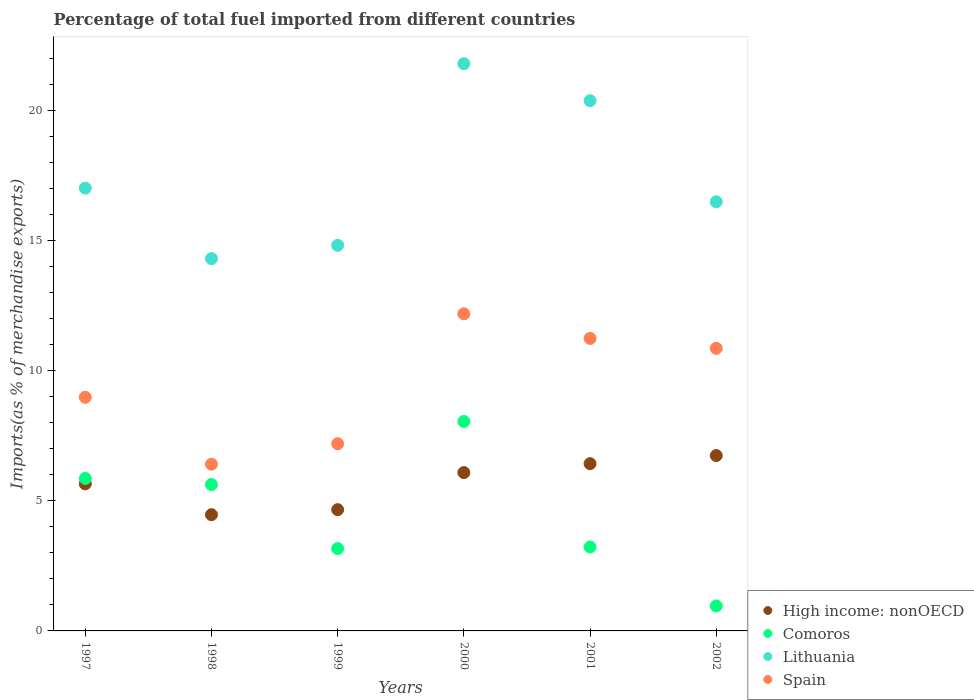How many different coloured dotlines are there?
Your response must be concise. 4. What is the percentage of imports to different countries in Comoros in 2000?
Make the answer very short. 8.04. Across all years, what is the maximum percentage of imports to different countries in Lithuania?
Offer a terse response. 21.78. Across all years, what is the minimum percentage of imports to different countries in Comoros?
Ensure brevity in your answer.  0.96. What is the total percentage of imports to different countries in High income: nonOECD in the graph?
Your answer should be compact. 34.01. What is the difference between the percentage of imports to different countries in Lithuania in 1998 and that in 2000?
Keep it short and to the point. -7.49. What is the difference between the percentage of imports to different countries in Comoros in 2002 and the percentage of imports to different countries in Spain in 1997?
Provide a short and direct response. -8.01. What is the average percentage of imports to different countries in High income: nonOECD per year?
Your answer should be compact. 5.67. In the year 1999, what is the difference between the percentage of imports to different countries in Lithuania and percentage of imports to different countries in Spain?
Offer a terse response. 7.62. What is the ratio of the percentage of imports to different countries in Lithuania in 2000 to that in 2001?
Your response must be concise. 1.07. What is the difference between the highest and the second highest percentage of imports to different countries in Comoros?
Give a very brief answer. 2.19. What is the difference between the highest and the lowest percentage of imports to different countries in High income: nonOECD?
Make the answer very short. 2.27. In how many years, is the percentage of imports to different countries in Comoros greater than the average percentage of imports to different countries in Comoros taken over all years?
Provide a short and direct response. 3. Is the sum of the percentage of imports to different countries in Comoros in 1997 and 1999 greater than the maximum percentage of imports to different countries in Spain across all years?
Keep it short and to the point. No. What is the difference between two consecutive major ticks on the Y-axis?
Ensure brevity in your answer.  5. Are the values on the major ticks of Y-axis written in scientific E-notation?
Your response must be concise. No. Does the graph contain any zero values?
Your answer should be very brief. No. How many legend labels are there?
Offer a terse response. 4. How are the legend labels stacked?
Offer a very short reply. Vertical. What is the title of the graph?
Your response must be concise. Percentage of total fuel imported from different countries. Does "Chad" appear as one of the legend labels in the graph?
Your answer should be compact. No. What is the label or title of the X-axis?
Keep it short and to the point. Years. What is the label or title of the Y-axis?
Offer a very short reply. Imports(as % of merchandise exports). What is the Imports(as % of merchandise exports) in High income: nonOECD in 1997?
Make the answer very short. 5.65. What is the Imports(as % of merchandise exports) of Comoros in 1997?
Offer a very short reply. 5.86. What is the Imports(as % of merchandise exports) of Lithuania in 1997?
Your response must be concise. 17. What is the Imports(as % of merchandise exports) in Spain in 1997?
Your answer should be compact. 8.97. What is the Imports(as % of merchandise exports) in High income: nonOECD in 1998?
Make the answer very short. 4.46. What is the Imports(as % of merchandise exports) of Comoros in 1998?
Your answer should be very brief. 5.62. What is the Imports(as % of merchandise exports) of Lithuania in 1998?
Your response must be concise. 14.3. What is the Imports(as % of merchandise exports) in Spain in 1998?
Your response must be concise. 6.4. What is the Imports(as % of merchandise exports) in High income: nonOECD in 1999?
Ensure brevity in your answer.  4.66. What is the Imports(as % of merchandise exports) in Comoros in 1999?
Offer a terse response. 3.16. What is the Imports(as % of merchandise exports) in Lithuania in 1999?
Ensure brevity in your answer.  14.81. What is the Imports(as % of merchandise exports) of Spain in 1999?
Ensure brevity in your answer.  7.19. What is the Imports(as % of merchandise exports) in High income: nonOECD in 2000?
Ensure brevity in your answer.  6.08. What is the Imports(as % of merchandise exports) in Comoros in 2000?
Offer a terse response. 8.04. What is the Imports(as % of merchandise exports) in Lithuania in 2000?
Your response must be concise. 21.78. What is the Imports(as % of merchandise exports) of Spain in 2000?
Your answer should be compact. 12.18. What is the Imports(as % of merchandise exports) in High income: nonOECD in 2001?
Provide a succinct answer. 6.42. What is the Imports(as % of merchandise exports) in Comoros in 2001?
Offer a very short reply. 3.22. What is the Imports(as % of merchandise exports) in Lithuania in 2001?
Ensure brevity in your answer.  20.36. What is the Imports(as % of merchandise exports) in Spain in 2001?
Provide a short and direct response. 11.23. What is the Imports(as % of merchandise exports) of High income: nonOECD in 2002?
Make the answer very short. 6.73. What is the Imports(as % of merchandise exports) in Comoros in 2002?
Your response must be concise. 0.96. What is the Imports(as % of merchandise exports) in Lithuania in 2002?
Offer a very short reply. 16.48. What is the Imports(as % of merchandise exports) of Spain in 2002?
Ensure brevity in your answer.  10.85. Across all years, what is the maximum Imports(as % of merchandise exports) in High income: nonOECD?
Keep it short and to the point. 6.73. Across all years, what is the maximum Imports(as % of merchandise exports) of Comoros?
Provide a short and direct response. 8.04. Across all years, what is the maximum Imports(as % of merchandise exports) in Lithuania?
Offer a terse response. 21.78. Across all years, what is the maximum Imports(as % of merchandise exports) in Spain?
Keep it short and to the point. 12.18. Across all years, what is the minimum Imports(as % of merchandise exports) in High income: nonOECD?
Keep it short and to the point. 4.46. Across all years, what is the minimum Imports(as % of merchandise exports) in Comoros?
Provide a succinct answer. 0.96. Across all years, what is the minimum Imports(as % of merchandise exports) of Lithuania?
Your response must be concise. 14.3. Across all years, what is the minimum Imports(as % of merchandise exports) of Spain?
Provide a succinct answer. 6.4. What is the total Imports(as % of merchandise exports) in High income: nonOECD in the graph?
Your answer should be very brief. 34.01. What is the total Imports(as % of merchandise exports) in Comoros in the graph?
Offer a terse response. 26.86. What is the total Imports(as % of merchandise exports) in Lithuania in the graph?
Ensure brevity in your answer.  104.73. What is the total Imports(as % of merchandise exports) of Spain in the graph?
Your answer should be compact. 56.82. What is the difference between the Imports(as % of merchandise exports) of High income: nonOECD in 1997 and that in 1998?
Offer a terse response. 1.18. What is the difference between the Imports(as % of merchandise exports) in Comoros in 1997 and that in 1998?
Give a very brief answer. 0.24. What is the difference between the Imports(as % of merchandise exports) in Lithuania in 1997 and that in 1998?
Ensure brevity in your answer.  2.71. What is the difference between the Imports(as % of merchandise exports) of Spain in 1997 and that in 1998?
Offer a terse response. 2.57. What is the difference between the Imports(as % of merchandise exports) of High income: nonOECD in 1997 and that in 1999?
Give a very brief answer. 0.99. What is the difference between the Imports(as % of merchandise exports) of Comoros in 1997 and that in 1999?
Your response must be concise. 2.7. What is the difference between the Imports(as % of merchandise exports) in Lithuania in 1997 and that in 1999?
Offer a very short reply. 2.2. What is the difference between the Imports(as % of merchandise exports) of Spain in 1997 and that in 1999?
Your response must be concise. 1.78. What is the difference between the Imports(as % of merchandise exports) of High income: nonOECD in 1997 and that in 2000?
Offer a terse response. -0.43. What is the difference between the Imports(as % of merchandise exports) in Comoros in 1997 and that in 2000?
Ensure brevity in your answer.  -2.19. What is the difference between the Imports(as % of merchandise exports) of Lithuania in 1997 and that in 2000?
Offer a terse response. -4.78. What is the difference between the Imports(as % of merchandise exports) in Spain in 1997 and that in 2000?
Keep it short and to the point. -3.21. What is the difference between the Imports(as % of merchandise exports) of High income: nonOECD in 1997 and that in 2001?
Your response must be concise. -0.78. What is the difference between the Imports(as % of merchandise exports) of Comoros in 1997 and that in 2001?
Offer a terse response. 2.63. What is the difference between the Imports(as % of merchandise exports) of Lithuania in 1997 and that in 2001?
Keep it short and to the point. -3.36. What is the difference between the Imports(as % of merchandise exports) in Spain in 1997 and that in 2001?
Ensure brevity in your answer.  -2.26. What is the difference between the Imports(as % of merchandise exports) of High income: nonOECD in 1997 and that in 2002?
Keep it short and to the point. -1.09. What is the difference between the Imports(as % of merchandise exports) in Comoros in 1997 and that in 2002?
Provide a succinct answer. 4.9. What is the difference between the Imports(as % of merchandise exports) of Lithuania in 1997 and that in 2002?
Offer a very short reply. 0.53. What is the difference between the Imports(as % of merchandise exports) of Spain in 1997 and that in 2002?
Your answer should be compact. -1.88. What is the difference between the Imports(as % of merchandise exports) of High income: nonOECD in 1998 and that in 1999?
Offer a very short reply. -0.19. What is the difference between the Imports(as % of merchandise exports) in Comoros in 1998 and that in 1999?
Provide a short and direct response. 2.46. What is the difference between the Imports(as % of merchandise exports) in Lithuania in 1998 and that in 1999?
Provide a succinct answer. -0.51. What is the difference between the Imports(as % of merchandise exports) in Spain in 1998 and that in 1999?
Make the answer very short. -0.79. What is the difference between the Imports(as % of merchandise exports) in High income: nonOECD in 1998 and that in 2000?
Provide a succinct answer. -1.62. What is the difference between the Imports(as % of merchandise exports) in Comoros in 1998 and that in 2000?
Provide a short and direct response. -2.42. What is the difference between the Imports(as % of merchandise exports) of Lithuania in 1998 and that in 2000?
Ensure brevity in your answer.  -7.49. What is the difference between the Imports(as % of merchandise exports) in Spain in 1998 and that in 2000?
Provide a succinct answer. -5.77. What is the difference between the Imports(as % of merchandise exports) of High income: nonOECD in 1998 and that in 2001?
Make the answer very short. -1.96. What is the difference between the Imports(as % of merchandise exports) of Comoros in 1998 and that in 2001?
Offer a terse response. 2.4. What is the difference between the Imports(as % of merchandise exports) in Lithuania in 1998 and that in 2001?
Your answer should be very brief. -6.06. What is the difference between the Imports(as % of merchandise exports) in Spain in 1998 and that in 2001?
Keep it short and to the point. -4.83. What is the difference between the Imports(as % of merchandise exports) of High income: nonOECD in 1998 and that in 2002?
Your response must be concise. -2.27. What is the difference between the Imports(as % of merchandise exports) in Comoros in 1998 and that in 2002?
Provide a succinct answer. 4.66. What is the difference between the Imports(as % of merchandise exports) in Lithuania in 1998 and that in 2002?
Make the answer very short. -2.18. What is the difference between the Imports(as % of merchandise exports) of Spain in 1998 and that in 2002?
Keep it short and to the point. -4.45. What is the difference between the Imports(as % of merchandise exports) of High income: nonOECD in 1999 and that in 2000?
Offer a very short reply. -1.42. What is the difference between the Imports(as % of merchandise exports) of Comoros in 1999 and that in 2000?
Make the answer very short. -4.88. What is the difference between the Imports(as % of merchandise exports) of Lithuania in 1999 and that in 2000?
Your answer should be compact. -6.97. What is the difference between the Imports(as % of merchandise exports) of Spain in 1999 and that in 2000?
Provide a succinct answer. -4.99. What is the difference between the Imports(as % of merchandise exports) in High income: nonOECD in 1999 and that in 2001?
Your response must be concise. -1.77. What is the difference between the Imports(as % of merchandise exports) of Comoros in 1999 and that in 2001?
Ensure brevity in your answer.  -0.06. What is the difference between the Imports(as % of merchandise exports) in Lithuania in 1999 and that in 2001?
Make the answer very short. -5.55. What is the difference between the Imports(as % of merchandise exports) in Spain in 1999 and that in 2001?
Keep it short and to the point. -4.04. What is the difference between the Imports(as % of merchandise exports) in High income: nonOECD in 1999 and that in 2002?
Your answer should be compact. -2.08. What is the difference between the Imports(as % of merchandise exports) of Comoros in 1999 and that in 2002?
Your response must be concise. 2.2. What is the difference between the Imports(as % of merchandise exports) in Lithuania in 1999 and that in 2002?
Your answer should be compact. -1.67. What is the difference between the Imports(as % of merchandise exports) in Spain in 1999 and that in 2002?
Provide a short and direct response. -3.66. What is the difference between the Imports(as % of merchandise exports) of High income: nonOECD in 2000 and that in 2001?
Make the answer very short. -0.34. What is the difference between the Imports(as % of merchandise exports) of Comoros in 2000 and that in 2001?
Provide a succinct answer. 4.82. What is the difference between the Imports(as % of merchandise exports) of Lithuania in 2000 and that in 2001?
Make the answer very short. 1.42. What is the difference between the Imports(as % of merchandise exports) of Spain in 2000 and that in 2001?
Provide a succinct answer. 0.94. What is the difference between the Imports(as % of merchandise exports) of High income: nonOECD in 2000 and that in 2002?
Offer a very short reply. -0.65. What is the difference between the Imports(as % of merchandise exports) in Comoros in 2000 and that in 2002?
Keep it short and to the point. 7.08. What is the difference between the Imports(as % of merchandise exports) of Lithuania in 2000 and that in 2002?
Your answer should be very brief. 5.3. What is the difference between the Imports(as % of merchandise exports) in Spain in 2000 and that in 2002?
Offer a terse response. 1.33. What is the difference between the Imports(as % of merchandise exports) in High income: nonOECD in 2001 and that in 2002?
Give a very brief answer. -0.31. What is the difference between the Imports(as % of merchandise exports) of Comoros in 2001 and that in 2002?
Your answer should be compact. 2.26. What is the difference between the Imports(as % of merchandise exports) in Lithuania in 2001 and that in 2002?
Offer a terse response. 3.88. What is the difference between the Imports(as % of merchandise exports) of Spain in 2001 and that in 2002?
Offer a very short reply. 0.38. What is the difference between the Imports(as % of merchandise exports) in High income: nonOECD in 1997 and the Imports(as % of merchandise exports) in Comoros in 1998?
Your response must be concise. 0.03. What is the difference between the Imports(as % of merchandise exports) of High income: nonOECD in 1997 and the Imports(as % of merchandise exports) of Lithuania in 1998?
Ensure brevity in your answer.  -8.65. What is the difference between the Imports(as % of merchandise exports) of High income: nonOECD in 1997 and the Imports(as % of merchandise exports) of Spain in 1998?
Provide a short and direct response. -0.76. What is the difference between the Imports(as % of merchandise exports) of Comoros in 1997 and the Imports(as % of merchandise exports) of Lithuania in 1998?
Your answer should be compact. -8.44. What is the difference between the Imports(as % of merchandise exports) of Comoros in 1997 and the Imports(as % of merchandise exports) of Spain in 1998?
Keep it short and to the point. -0.55. What is the difference between the Imports(as % of merchandise exports) in Lithuania in 1997 and the Imports(as % of merchandise exports) in Spain in 1998?
Provide a succinct answer. 10.6. What is the difference between the Imports(as % of merchandise exports) in High income: nonOECD in 1997 and the Imports(as % of merchandise exports) in Comoros in 1999?
Your answer should be very brief. 2.49. What is the difference between the Imports(as % of merchandise exports) of High income: nonOECD in 1997 and the Imports(as % of merchandise exports) of Lithuania in 1999?
Ensure brevity in your answer.  -9.16. What is the difference between the Imports(as % of merchandise exports) of High income: nonOECD in 1997 and the Imports(as % of merchandise exports) of Spain in 1999?
Keep it short and to the point. -1.54. What is the difference between the Imports(as % of merchandise exports) of Comoros in 1997 and the Imports(as % of merchandise exports) of Lithuania in 1999?
Your response must be concise. -8.95. What is the difference between the Imports(as % of merchandise exports) in Comoros in 1997 and the Imports(as % of merchandise exports) in Spain in 1999?
Your response must be concise. -1.33. What is the difference between the Imports(as % of merchandise exports) in Lithuania in 1997 and the Imports(as % of merchandise exports) in Spain in 1999?
Your response must be concise. 9.82. What is the difference between the Imports(as % of merchandise exports) of High income: nonOECD in 1997 and the Imports(as % of merchandise exports) of Comoros in 2000?
Your answer should be compact. -2.4. What is the difference between the Imports(as % of merchandise exports) in High income: nonOECD in 1997 and the Imports(as % of merchandise exports) in Lithuania in 2000?
Provide a succinct answer. -16.14. What is the difference between the Imports(as % of merchandise exports) of High income: nonOECD in 1997 and the Imports(as % of merchandise exports) of Spain in 2000?
Give a very brief answer. -6.53. What is the difference between the Imports(as % of merchandise exports) of Comoros in 1997 and the Imports(as % of merchandise exports) of Lithuania in 2000?
Your response must be concise. -15.93. What is the difference between the Imports(as % of merchandise exports) in Comoros in 1997 and the Imports(as % of merchandise exports) in Spain in 2000?
Offer a terse response. -6.32. What is the difference between the Imports(as % of merchandise exports) in Lithuania in 1997 and the Imports(as % of merchandise exports) in Spain in 2000?
Provide a succinct answer. 4.83. What is the difference between the Imports(as % of merchandise exports) in High income: nonOECD in 1997 and the Imports(as % of merchandise exports) in Comoros in 2001?
Give a very brief answer. 2.42. What is the difference between the Imports(as % of merchandise exports) of High income: nonOECD in 1997 and the Imports(as % of merchandise exports) of Lithuania in 2001?
Your answer should be very brief. -14.71. What is the difference between the Imports(as % of merchandise exports) in High income: nonOECD in 1997 and the Imports(as % of merchandise exports) in Spain in 2001?
Offer a terse response. -5.59. What is the difference between the Imports(as % of merchandise exports) of Comoros in 1997 and the Imports(as % of merchandise exports) of Lithuania in 2001?
Give a very brief answer. -14.51. What is the difference between the Imports(as % of merchandise exports) of Comoros in 1997 and the Imports(as % of merchandise exports) of Spain in 2001?
Make the answer very short. -5.38. What is the difference between the Imports(as % of merchandise exports) in Lithuania in 1997 and the Imports(as % of merchandise exports) in Spain in 2001?
Give a very brief answer. 5.77. What is the difference between the Imports(as % of merchandise exports) in High income: nonOECD in 1997 and the Imports(as % of merchandise exports) in Comoros in 2002?
Provide a succinct answer. 4.69. What is the difference between the Imports(as % of merchandise exports) of High income: nonOECD in 1997 and the Imports(as % of merchandise exports) of Lithuania in 2002?
Make the answer very short. -10.83. What is the difference between the Imports(as % of merchandise exports) in High income: nonOECD in 1997 and the Imports(as % of merchandise exports) in Spain in 2002?
Your answer should be very brief. -5.21. What is the difference between the Imports(as % of merchandise exports) in Comoros in 1997 and the Imports(as % of merchandise exports) in Lithuania in 2002?
Keep it short and to the point. -10.62. What is the difference between the Imports(as % of merchandise exports) of Comoros in 1997 and the Imports(as % of merchandise exports) of Spain in 2002?
Offer a very short reply. -5. What is the difference between the Imports(as % of merchandise exports) of Lithuania in 1997 and the Imports(as % of merchandise exports) of Spain in 2002?
Your answer should be compact. 6.15. What is the difference between the Imports(as % of merchandise exports) of High income: nonOECD in 1998 and the Imports(as % of merchandise exports) of Comoros in 1999?
Your response must be concise. 1.3. What is the difference between the Imports(as % of merchandise exports) in High income: nonOECD in 1998 and the Imports(as % of merchandise exports) in Lithuania in 1999?
Keep it short and to the point. -10.35. What is the difference between the Imports(as % of merchandise exports) of High income: nonOECD in 1998 and the Imports(as % of merchandise exports) of Spain in 1999?
Provide a short and direct response. -2.73. What is the difference between the Imports(as % of merchandise exports) of Comoros in 1998 and the Imports(as % of merchandise exports) of Lithuania in 1999?
Give a very brief answer. -9.19. What is the difference between the Imports(as % of merchandise exports) of Comoros in 1998 and the Imports(as % of merchandise exports) of Spain in 1999?
Provide a short and direct response. -1.57. What is the difference between the Imports(as % of merchandise exports) in Lithuania in 1998 and the Imports(as % of merchandise exports) in Spain in 1999?
Your response must be concise. 7.11. What is the difference between the Imports(as % of merchandise exports) of High income: nonOECD in 1998 and the Imports(as % of merchandise exports) of Comoros in 2000?
Your answer should be very brief. -3.58. What is the difference between the Imports(as % of merchandise exports) of High income: nonOECD in 1998 and the Imports(as % of merchandise exports) of Lithuania in 2000?
Provide a short and direct response. -17.32. What is the difference between the Imports(as % of merchandise exports) of High income: nonOECD in 1998 and the Imports(as % of merchandise exports) of Spain in 2000?
Offer a terse response. -7.71. What is the difference between the Imports(as % of merchandise exports) of Comoros in 1998 and the Imports(as % of merchandise exports) of Lithuania in 2000?
Provide a short and direct response. -16.16. What is the difference between the Imports(as % of merchandise exports) in Comoros in 1998 and the Imports(as % of merchandise exports) in Spain in 2000?
Provide a succinct answer. -6.56. What is the difference between the Imports(as % of merchandise exports) of Lithuania in 1998 and the Imports(as % of merchandise exports) of Spain in 2000?
Keep it short and to the point. 2.12. What is the difference between the Imports(as % of merchandise exports) of High income: nonOECD in 1998 and the Imports(as % of merchandise exports) of Comoros in 2001?
Ensure brevity in your answer.  1.24. What is the difference between the Imports(as % of merchandise exports) of High income: nonOECD in 1998 and the Imports(as % of merchandise exports) of Lithuania in 2001?
Provide a succinct answer. -15.9. What is the difference between the Imports(as % of merchandise exports) in High income: nonOECD in 1998 and the Imports(as % of merchandise exports) in Spain in 2001?
Make the answer very short. -6.77. What is the difference between the Imports(as % of merchandise exports) of Comoros in 1998 and the Imports(as % of merchandise exports) of Lithuania in 2001?
Offer a very short reply. -14.74. What is the difference between the Imports(as % of merchandise exports) of Comoros in 1998 and the Imports(as % of merchandise exports) of Spain in 2001?
Keep it short and to the point. -5.61. What is the difference between the Imports(as % of merchandise exports) in Lithuania in 1998 and the Imports(as % of merchandise exports) in Spain in 2001?
Offer a very short reply. 3.06. What is the difference between the Imports(as % of merchandise exports) of High income: nonOECD in 1998 and the Imports(as % of merchandise exports) of Comoros in 2002?
Your response must be concise. 3.5. What is the difference between the Imports(as % of merchandise exports) of High income: nonOECD in 1998 and the Imports(as % of merchandise exports) of Lithuania in 2002?
Offer a very short reply. -12.02. What is the difference between the Imports(as % of merchandise exports) of High income: nonOECD in 1998 and the Imports(as % of merchandise exports) of Spain in 2002?
Your response must be concise. -6.39. What is the difference between the Imports(as % of merchandise exports) in Comoros in 1998 and the Imports(as % of merchandise exports) in Lithuania in 2002?
Give a very brief answer. -10.86. What is the difference between the Imports(as % of merchandise exports) in Comoros in 1998 and the Imports(as % of merchandise exports) in Spain in 2002?
Give a very brief answer. -5.23. What is the difference between the Imports(as % of merchandise exports) in Lithuania in 1998 and the Imports(as % of merchandise exports) in Spain in 2002?
Make the answer very short. 3.44. What is the difference between the Imports(as % of merchandise exports) in High income: nonOECD in 1999 and the Imports(as % of merchandise exports) in Comoros in 2000?
Make the answer very short. -3.39. What is the difference between the Imports(as % of merchandise exports) in High income: nonOECD in 1999 and the Imports(as % of merchandise exports) in Lithuania in 2000?
Ensure brevity in your answer.  -17.13. What is the difference between the Imports(as % of merchandise exports) in High income: nonOECD in 1999 and the Imports(as % of merchandise exports) in Spain in 2000?
Your answer should be very brief. -7.52. What is the difference between the Imports(as % of merchandise exports) of Comoros in 1999 and the Imports(as % of merchandise exports) of Lithuania in 2000?
Offer a very short reply. -18.62. What is the difference between the Imports(as % of merchandise exports) in Comoros in 1999 and the Imports(as % of merchandise exports) in Spain in 2000?
Provide a short and direct response. -9.02. What is the difference between the Imports(as % of merchandise exports) of Lithuania in 1999 and the Imports(as % of merchandise exports) of Spain in 2000?
Offer a very short reply. 2.63. What is the difference between the Imports(as % of merchandise exports) in High income: nonOECD in 1999 and the Imports(as % of merchandise exports) in Comoros in 2001?
Offer a very short reply. 1.43. What is the difference between the Imports(as % of merchandise exports) in High income: nonOECD in 1999 and the Imports(as % of merchandise exports) in Lithuania in 2001?
Keep it short and to the point. -15.71. What is the difference between the Imports(as % of merchandise exports) in High income: nonOECD in 1999 and the Imports(as % of merchandise exports) in Spain in 2001?
Your answer should be compact. -6.58. What is the difference between the Imports(as % of merchandise exports) of Comoros in 1999 and the Imports(as % of merchandise exports) of Lithuania in 2001?
Your answer should be compact. -17.2. What is the difference between the Imports(as % of merchandise exports) in Comoros in 1999 and the Imports(as % of merchandise exports) in Spain in 2001?
Give a very brief answer. -8.07. What is the difference between the Imports(as % of merchandise exports) in Lithuania in 1999 and the Imports(as % of merchandise exports) in Spain in 2001?
Offer a terse response. 3.58. What is the difference between the Imports(as % of merchandise exports) in High income: nonOECD in 1999 and the Imports(as % of merchandise exports) in Comoros in 2002?
Offer a terse response. 3.7. What is the difference between the Imports(as % of merchandise exports) of High income: nonOECD in 1999 and the Imports(as % of merchandise exports) of Lithuania in 2002?
Provide a succinct answer. -11.82. What is the difference between the Imports(as % of merchandise exports) of High income: nonOECD in 1999 and the Imports(as % of merchandise exports) of Spain in 2002?
Your response must be concise. -6.2. What is the difference between the Imports(as % of merchandise exports) of Comoros in 1999 and the Imports(as % of merchandise exports) of Lithuania in 2002?
Offer a terse response. -13.32. What is the difference between the Imports(as % of merchandise exports) in Comoros in 1999 and the Imports(as % of merchandise exports) in Spain in 2002?
Your response must be concise. -7.69. What is the difference between the Imports(as % of merchandise exports) in Lithuania in 1999 and the Imports(as % of merchandise exports) in Spain in 2002?
Provide a succinct answer. 3.96. What is the difference between the Imports(as % of merchandise exports) in High income: nonOECD in 2000 and the Imports(as % of merchandise exports) in Comoros in 2001?
Offer a very short reply. 2.86. What is the difference between the Imports(as % of merchandise exports) in High income: nonOECD in 2000 and the Imports(as % of merchandise exports) in Lithuania in 2001?
Provide a succinct answer. -14.28. What is the difference between the Imports(as % of merchandise exports) of High income: nonOECD in 2000 and the Imports(as % of merchandise exports) of Spain in 2001?
Your answer should be very brief. -5.15. What is the difference between the Imports(as % of merchandise exports) in Comoros in 2000 and the Imports(as % of merchandise exports) in Lithuania in 2001?
Make the answer very short. -12.32. What is the difference between the Imports(as % of merchandise exports) in Comoros in 2000 and the Imports(as % of merchandise exports) in Spain in 2001?
Provide a short and direct response. -3.19. What is the difference between the Imports(as % of merchandise exports) in Lithuania in 2000 and the Imports(as % of merchandise exports) in Spain in 2001?
Your answer should be compact. 10.55. What is the difference between the Imports(as % of merchandise exports) of High income: nonOECD in 2000 and the Imports(as % of merchandise exports) of Comoros in 2002?
Provide a short and direct response. 5.12. What is the difference between the Imports(as % of merchandise exports) in High income: nonOECD in 2000 and the Imports(as % of merchandise exports) in Lithuania in 2002?
Keep it short and to the point. -10.4. What is the difference between the Imports(as % of merchandise exports) of High income: nonOECD in 2000 and the Imports(as % of merchandise exports) of Spain in 2002?
Give a very brief answer. -4.77. What is the difference between the Imports(as % of merchandise exports) of Comoros in 2000 and the Imports(as % of merchandise exports) of Lithuania in 2002?
Provide a short and direct response. -8.44. What is the difference between the Imports(as % of merchandise exports) of Comoros in 2000 and the Imports(as % of merchandise exports) of Spain in 2002?
Offer a very short reply. -2.81. What is the difference between the Imports(as % of merchandise exports) of Lithuania in 2000 and the Imports(as % of merchandise exports) of Spain in 2002?
Keep it short and to the point. 10.93. What is the difference between the Imports(as % of merchandise exports) of High income: nonOECD in 2001 and the Imports(as % of merchandise exports) of Comoros in 2002?
Your answer should be compact. 5.47. What is the difference between the Imports(as % of merchandise exports) in High income: nonOECD in 2001 and the Imports(as % of merchandise exports) in Lithuania in 2002?
Offer a very short reply. -10.06. What is the difference between the Imports(as % of merchandise exports) in High income: nonOECD in 2001 and the Imports(as % of merchandise exports) in Spain in 2002?
Make the answer very short. -4.43. What is the difference between the Imports(as % of merchandise exports) in Comoros in 2001 and the Imports(as % of merchandise exports) in Lithuania in 2002?
Your answer should be very brief. -13.26. What is the difference between the Imports(as % of merchandise exports) of Comoros in 2001 and the Imports(as % of merchandise exports) of Spain in 2002?
Provide a short and direct response. -7.63. What is the difference between the Imports(as % of merchandise exports) of Lithuania in 2001 and the Imports(as % of merchandise exports) of Spain in 2002?
Provide a succinct answer. 9.51. What is the average Imports(as % of merchandise exports) in High income: nonOECD per year?
Make the answer very short. 5.67. What is the average Imports(as % of merchandise exports) in Comoros per year?
Your answer should be very brief. 4.48. What is the average Imports(as % of merchandise exports) of Lithuania per year?
Provide a short and direct response. 17.46. What is the average Imports(as % of merchandise exports) of Spain per year?
Offer a very short reply. 9.47. In the year 1997, what is the difference between the Imports(as % of merchandise exports) of High income: nonOECD and Imports(as % of merchandise exports) of Comoros?
Give a very brief answer. -0.21. In the year 1997, what is the difference between the Imports(as % of merchandise exports) in High income: nonOECD and Imports(as % of merchandise exports) in Lithuania?
Keep it short and to the point. -11.36. In the year 1997, what is the difference between the Imports(as % of merchandise exports) of High income: nonOECD and Imports(as % of merchandise exports) of Spain?
Give a very brief answer. -3.32. In the year 1997, what is the difference between the Imports(as % of merchandise exports) of Comoros and Imports(as % of merchandise exports) of Lithuania?
Your answer should be compact. -11.15. In the year 1997, what is the difference between the Imports(as % of merchandise exports) of Comoros and Imports(as % of merchandise exports) of Spain?
Your answer should be compact. -3.11. In the year 1997, what is the difference between the Imports(as % of merchandise exports) of Lithuania and Imports(as % of merchandise exports) of Spain?
Your answer should be compact. 8.03. In the year 1998, what is the difference between the Imports(as % of merchandise exports) of High income: nonOECD and Imports(as % of merchandise exports) of Comoros?
Your answer should be very brief. -1.16. In the year 1998, what is the difference between the Imports(as % of merchandise exports) of High income: nonOECD and Imports(as % of merchandise exports) of Lithuania?
Give a very brief answer. -9.83. In the year 1998, what is the difference between the Imports(as % of merchandise exports) in High income: nonOECD and Imports(as % of merchandise exports) in Spain?
Your response must be concise. -1.94. In the year 1998, what is the difference between the Imports(as % of merchandise exports) in Comoros and Imports(as % of merchandise exports) in Lithuania?
Provide a short and direct response. -8.68. In the year 1998, what is the difference between the Imports(as % of merchandise exports) in Comoros and Imports(as % of merchandise exports) in Spain?
Provide a short and direct response. -0.78. In the year 1998, what is the difference between the Imports(as % of merchandise exports) in Lithuania and Imports(as % of merchandise exports) in Spain?
Offer a terse response. 7.89. In the year 1999, what is the difference between the Imports(as % of merchandise exports) of High income: nonOECD and Imports(as % of merchandise exports) of Comoros?
Ensure brevity in your answer.  1.5. In the year 1999, what is the difference between the Imports(as % of merchandise exports) of High income: nonOECD and Imports(as % of merchandise exports) of Lithuania?
Make the answer very short. -10.15. In the year 1999, what is the difference between the Imports(as % of merchandise exports) in High income: nonOECD and Imports(as % of merchandise exports) in Spain?
Give a very brief answer. -2.53. In the year 1999, what is the difference between the Imports(as % of merchandise exports) in Comoros and Imports(as % of merchandise exports) in Lithuania?
Offer a terse response. -11.65. In the year 1999, what is the difference between the Imports(as % of merchandise exports) in Comoros and Imports(as % of merchandise exports) in Spain?
Make the answer very short. -4.03. In the year 1999, what is the difference between the Imports(as % of merchandise exports) of Lithuania and Imports(as % of merchandise exports) of Spain?
Ensure brevity in your answer.  7.62. In the year 2000, what is the difference between the Imports(as % of merchandise exports) in High income: nonOECD and Imports(as % of merchandise exports) in Comoros?
Provide a succinct answer. -1.96. In the year 2000, what is the difference between the Imports(as % of merchandise exports) in High income: nonOECD and Imports(as % of merchandise exports) in Lithuania?
Your answer should be very brief. -15.7. In the year 2000, what is the difference between the Imports(as % of merchandise exports) of High income: nonOECD and Imports(as % of merchandise exports) of Spain?
Provide a succinct answer. -6.1. In the year 2000, what is the difference between the Imports(as % of merchandise exports) in Comoros and Imports(as % of merchandise exports) in Lithuania?
Ensure brevity in your answer.  -13.74. In the year 2000, what is the difference between the Imports(as % of merchandise exports) in Comoros and Imports(as % of merchandise exports) in Spain?
Your answer should be compact. -4.13. In the year 2000, what is the difference between the Imports(as % of merchandise exports) in Lithuania and Imports(as % of merchandise exports) in Spain?
Your response must be concise. 9.61. In the year 2001, what is the difference between the Imports(as % of merchandise exports) of High income: nonOECD and Imports(as % of merchandise exports) of Comoros?
Your answer should be compact. 3.2. In the year 2001, what is the difference between the Imports(as % of merchandise exports) in High income: nonOECD and Imports(as % of merchandise exports) in Lithuania?
Your answer should be very brief. -13.94. In the year 2001, what is the difference between the Imports(as % of merchandise exports) in High income: nonOECD and Imports(as % of merchandise exports) in Spain?
Ensure brevity in your answer.  -4.81. In the year 2001, what is the difference between the Imports(as % of merchandise exports) in Comoros and Imports(as % of merchandise exports) in Lithuania?
Provide a succinct answer. -17.14. In the year 2001, what is the difference between the Imports(as % of merchandise exports) in Comoros and Imports(as % of merchandise exports) in Spain?
Offer a terse response. -8.01. In the year 2001, what is the difference between the Imports(as % of merchandise exports) in Lithuania and Imports(as % of merchandise exports) in Spain?
Your answer should be compact. 9.13. In the year 2002, what is the difference between the Imports(as % of merchandise exports) of High income: nonOECD and Imports(as % of merchandise exports) of Comoros?
Keep it short and to the point. 5.78. In the year 2002, what is the difference between the Imports(as % of merchandise exports) of High income: nonOECD and Imports(as % of merchandise exports) of Lithuania?
Give a very brief answer. -9.74. In the year 2002, what is the difference between the Imports(as % of merchandise exports) in High income: nonOECD and Imports(as % of merchandise exports) in Spain?
Your answer should be very brief. -4.12. In the year 2002, what is the difference between the Imports(as % of merchandise exports) of Comoros and Imports(as % of merchandise exports) of Lithuania?
Offer a terse response. -15.52. In the year 2002, what is the difference between the Imports(as % of merchandise exports) in Comoros and Imports(as % of merchandise exports) in Spain?
Offer a terse response. -9.89. In the year 2002, what is the difference between the Imports(as % of merchandise exports) in Lithuania and Imports(as % of merchandise exports) in Spain?
Provide a short and direct response. 5.63. What is the ratio of the Imports(as % of merchandise exports) of High income: nonOECD in 1997 to that in 1998?
Provide a short and direct response. 1.27. What is the ratio of the Imports(as % of merchandise exports) of Comoros in 1997 to that in 1998?
Provide a succinct answer. 1.04. What is the ratio of the Imports(as % of merchandise exports) of Lithuania in 1997 to that in 1998?
Provide a short and direct response. 1.19. What is the ratio of the Imports(as % of merchandise exports) in Spain in 1997 to that in 1998?
Your answer should be very brief. 1.4. What is the ratio of the Imports(as % of merchandise exports) in High income: nonOECD in 1997 to that in 1999?
Your answer should be very brief. 1.21. What is the ratio of the Imports(as % of merchandise exports) in Comoros in 1997 to that in 1999?
Your answer should be compact. 1.85. What is the ratio of the Imports(as % of merchandise exports) of Lithuania in 1997 to that in 1999?
Make the answer very short. 1.15. What is the ratio of the Imports(as % of merchandise exports) of Spain in 1997 to that in 1999?
Your response must be concise. 1.25. What is the ratio of the Imports(as % of merchandise exports) of High income: nonOECD in 1997 to that in 2000?
Your response must be concise. 0.93. What is the ratio of the Imports(as % of merchandise exports) in Comoros in 1997 to that in 2000?
Give a very brief answer. 0.73. What is the ratio of the Imports(as % of merchandise exports) in Lithuania in 1997 to that in 2000?
Offer a very short reply. 0.78. What is the ratio of the Imports(as % of merchandise exports) in Spain in 1997 to that in 2000?
Offer a terse response. 0.74. What is the ratio of the Imports(as % of merchandise exports) of High income: nonOECD in 1997 to that in 2001?
Your response must be concise. 0.88. What is the ratio of the Imports(as % of merchandise exports) in Comoros in 1997 to that in 2001?
Make the answer very short. 1.82. What is the ratio of the Imports(as % of merchandise exports) in Lithuania in 1997 to that in 2001?
Provide a succinct answer. 0.84. What is the ratio of the Imports(as % of merchandise exports) of Spain in 1997 to that in 2001?
Keep it short and to the point. 0.8. What is the ratio of the Imports(as % of merchandise exports) in High income: nonOECD in 1997 to that in 2002?
Your answer should be compact. 0.84. What is the ratio of the Imports(as % of merchandise exports) in Comoros in 1997 to that in 2002?
Offer a terse response. 6.11. What is the ratio of the Imports(as % of merchandise exports) of Lithuania in 1997 to that in 2002?
Offer a very short reply. 1.03. What is the ratio of the Imports(as % of merchandise exports) in Spain in 1997 to that in 2002?
Your answer should be compact. 0.83. What is the ratio of the Imports(as % of merchandise exports) in High income: nonOECD in 1998 to that in 1999?
Offer a very short reply. 0.96. What is the ratio of the Imports(as % of merchandise exports) in Comoros in 1998 to that in 1999?
Offer a terse response. 1.78. What is the ratio of the Imports(as % of merchandise exports) in Lithuania in 1998 to that in 1999?
Keep it short and to the point. 0.97. What is the ratio of the Imports(as % of merchandise exports) of Spain in 1998 to that in 1999?
Make the answer very short. 0.89. What is the ratio of the Imports(as % of merchandise exports) in High income: nonOECD in 1998 to that in 2000?
Ensure brevity in your answer.  0.73. What is the ratio of the Imports(as % of merchandise exports) in Comoros in 1998 to that in 2000?
Your answer should be very brief. 0.7. What is the ratio of the Imports(as % of merchandise exports) of Lithuania in 1998 to that in 2000?
Your answer should be compact. 0.66. What is the ratio of the Imports(as % of merchandise exports) of Spain in 1998 to that in 2000?
Your answer should be compact. 0.53. What is the ratio of the Imports(as % of merchandise exports) in High income: nonOECD in 1998 to that in 2001?
Your answer should be compact. 0.69. What is the ratio of the Imports(as % of merchandise exports) of Comoros in 1998 to that in 2001?
Your answer should be compact. 1.74. What is the ratio of the Imports(as % of merchandise exports) in Lithuania in 1998 to that in 2001?
Offer a very short reply. 0.7. What is the ratio of the Imports(as % of merchandise exports) in Spain in 1998 to that in 2001?
Your response must be concise. 0.57. What is the ratio of the Imports(as % of merchandise exports) of High income: nonOECD in 1998 to that in 2002?
Make the answer very short. 0.66. What is the ratio of the Imports(as % of merchandise exports) in Comoros in 1998 to that in 2002?
Ensure brevity in your answer.  5.86. What is the ratio of the Imports(as % of merchandise exports) of Lithuania in 1998 to that in 2002?
Provide a short and direct response. 0.87. What is the ratio of the Imports(as % of merchandise exports) of Spain in 1998 to that in 2002?
Make the answer very short. 0.59. What is the ratio of the Imports(as % of merchandise exports) of High income: nonOECD in 1999 to that in 2000?
Your answer should be compact. 0.77. What is the ratio of the Imports(as % of merchandise exports) in Comoros in 1999 to that in 2000?
Keep it short and to the point. 0.39. What is the ratio of the Imports(as % of merchandise exports) in Lithuania in 1999 to that in 2000?
Provide a succinct answer. 0.68. What is the ratio of the Imports(as % of merchandise exports) of Spain in 1999 to that in 2000?
Your response must be concise. 0.59. What is the ratio of the Imports(as % of merchandise exports) in High income: nonOECD in 1999 to that in 2001?
Ensure brevity in your answer.  0.72. What is the ratio of the Imports(as % of merchandise exports) of Comoros in 1999 to that in 2001?
Ensure brevity in your answer.  0.98. What is the ratio of the Imports(as % of merchandise exports) of Lithuania in 1999 to that in 2001?
Offer a very short reply. 0.73. What is the ratio of the Imports(as % of merchandise exports) of Spain in 1999 to that in 2001?
Give a very brief answer. 0.64. What is the ratio of the Imports(as % of merchandise exports) in High income: nonOECD in 1999 to that in 2002?
Ensure brevity in your answer.  0.69. What is the ratio of the Imports(as % of merchandise exports) in Comoros in 1999 to that in 2002?
Provide a short and direct response. 3.3. What is the ratio of the Imports(as % of merchandise exports) in Lithuania in 1999 to that in 2002?
Provide a succinct answer. 0.9. What is the ratio of the Imports(as % of merchandise exports) of Spain in 1999 to that in 2002?
Your answer should be compact. 0.66. What is the ratio of the Imports(as % of merchandise exports) of High income: nonOECD in 2000 to that in 2001?
Provide a short and direct response. 0.95. What is the ratio of the Imports(as % of merchandise exports) of Comoros in 2000 to that in 2001?
Provide a short and direct response. 2.5. What is the ratio of the Imports(as % of merchandise exports) in Lithuania in 2000 to that in 2001?
Ensure brevity in your answer.  1.07. What is the ratio of the Imports(as % of merchandise exports) of Spain in 2000 to that in 2001?
Ensure brevity in your answer.  1.08. What is the ratio of the Imports(as % of merchandise exports) of High income: nonOECD in 2000 to that in 2002?
Your answer should be very brief. 0.9. What is the ratio of the Imports(as % of merchandise exports) in Comoros in 2000 to that in 2002?
Give a very brief answer. 8.39. What is the ratio of the Imports(as % of merchandise exports) of Lithuania in 2000 to that in 2002?
Ensure brevity in your answer.  1.32. What is the ratio of the Imports(as % of merchandise exports) in Spain in 2000 to that in 2002?
Provide a succinct answer. 1.12. What is the ratio of the Imports(as % of merchandise exports) of High income: nonOECD in 2001 to that in 2002?
Make the answer very short. 0.95. What is the ratio of the Imports(as % of merchandise exports) of Comoros in 2001 to that in 2002?
Your answer should be compact. 3.36. What is the ratio of the Imports(as % of merchandise exports) of Lithuania in 2001 to that in 2002?
Your answer should be compact. 1.24. What is the ratio of the Imports(as % of merchandise exports) in Spain in 2001 to that in 2002?
Keep it short and to the point. 1.04. What is the difference between the highest and the second highest Imports(as % of merchandise exports) of High income: nonOECD?
Provide a succinct answer. 0.31. What is the difference between the highest and the second highest Imports(as % of merchandise exports) of Comoros?
Offer a very short reply. 2.19. What is the difference between the highest and the second highest Imports(as % of merchandise exports) of Lithuania?
Offer a very short reply. 1.42. What is the difference between the highest and the second highest Imports(as % of merchandise exports) in Spain?
Offer a terse response. 0.94. What is the difference between the highest and the lowest Imports(as % of merchandise exports) of High income: nonOECD?
Give a very brief answer. 2.27. What is the difference between the highest and the lowest Imports(as % of merchandise exports) of Comoros?
Provide a succinct answer. 7.08. What is the difference between the highest and the lowest Imports(as % of merchandise exports) in Lithuania?
Offer a very short reply. 7.49. What is the difference between the highest and the lowest Imports(as % of merchandise exports) of Spain?
Give a very brief answer. 5.77. 